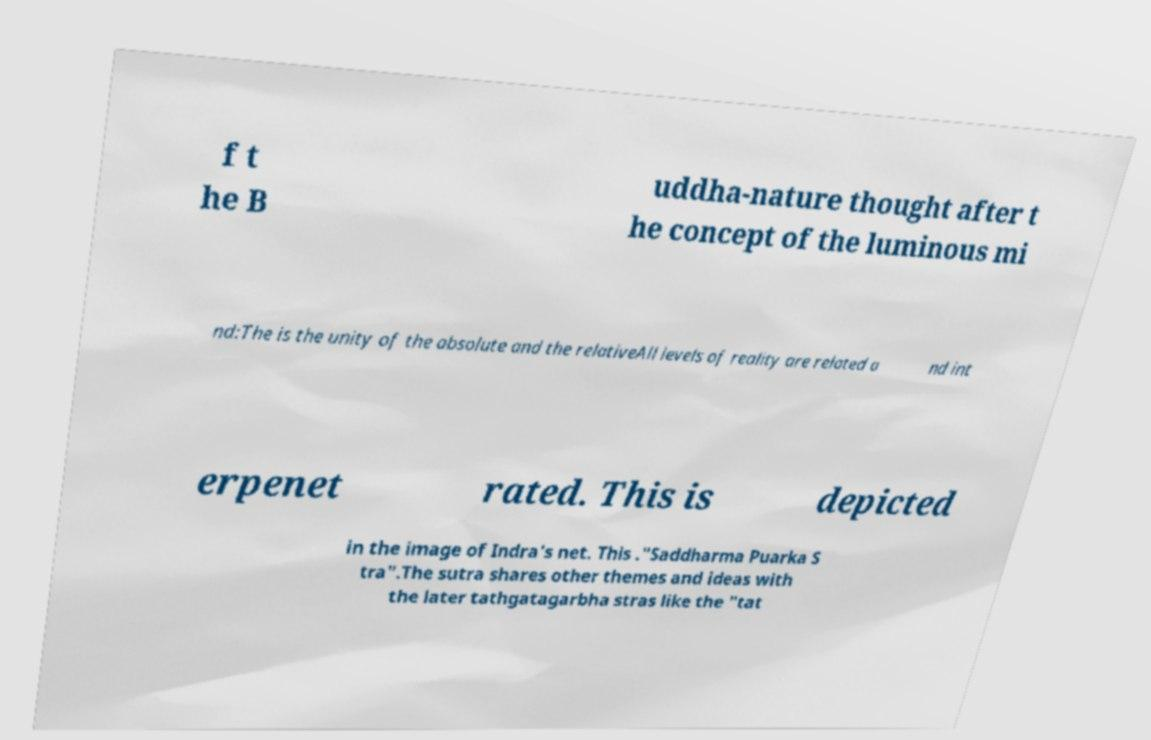Could you extract and type out the text from this image? f t he B uddha-nature thought after t he concept of the luminous mi nd:The is the unity of the absolute and the relativeAll levels of reality are related a nd int erpenet rated. This is depicted in the image of Indra's net. This ."Saddharma Puarka S tra".The sutra shares other themes and ideas with the later tathgatagarbha stras like the "tat 